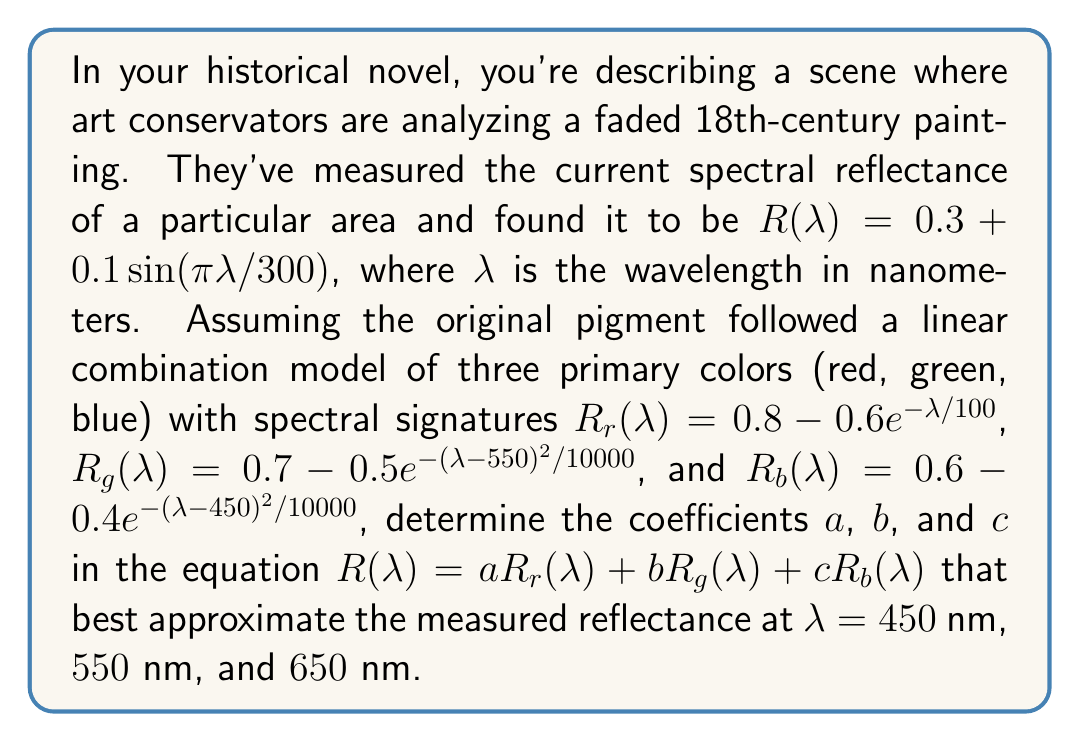Provide a solution to this math problem. To solve this inverse problem and determine the original color pigments, we'll follow these steps:

1) First, we need to calculate the measured reflectance $R(λ)$ at the given wavelengths:

   At $λ = 450$ nm: $R(450) = 0.3 + 0.1\sin(π*450/300) = 0.3 + 0.1 = 0.4$
   At $λ = 550$ nm: $R(550) = 0.3 + 0.1\sin(π*550/300) = 0.3 - 0.1 = 0.2$
   At $λ = 650$ nm: $R(650) = 0.3 + 0.1\sin(π*650/300) = 0.3 + 0.1 = 0.4$

2) Next, we calculate the reflectance of each primary color at these wavelengths:

   Red:
   $R_r(450) = 0.8 - 0.6e^{-450/100} ≈ 0.7768$
   $R_r(550) = 0.8 - 0.6e^{-550/100} ≈ 0.7947$
   $R_r(650) = 0.8 - 0.6e^{-650/100} ≈ 0.7980$

   Green:
   $R_g(450) = 0.7 - 0.5e^{-(450-550)^2/10000} ≈ 0.3894$
   $R_g(550) = 0.7 - 0.5e^{-(550-550)^2/10000} = 0.2$
   $R_g(650) = 0.7 - 0.5e^{-(650-550)^2/10000} ≈ 0.3894$

   Blue:
   $R_b(450) = 0.6 - 0.4e^{-(450-450)^2/10000} = 0.2$
   $R_b(550) = 0.6 - 0.4e^{-(550-450)^2/10000} ≈ 0.3894$
   $R_b(650) = 0.6 - 0.4e^{-(650-450)^2/10000} ≈ 0.5788$

3) Now we can set up a system of linear equations:

   $0.7768a + 0.3894b + 0.2000c = 0.4$
   $0.7947a + 0.2000b + 0.3894c = 0.2$
   $0.7980a + 0.3894b + 0.5788c = 0.4$

4) We can solve this system using matrix methods or elimination. Using a matrix solver, we get:

   $a ≈ 0.1667$
   $b ≈ 0.3333$
   $c ≈ 0.5000$

These coefficients represent the proportions of red, green, and blue pigments in the original painting.
Answer: $a ≈ 0.1667, b ≈ 0.3333, c ≈ 0.5000$ 